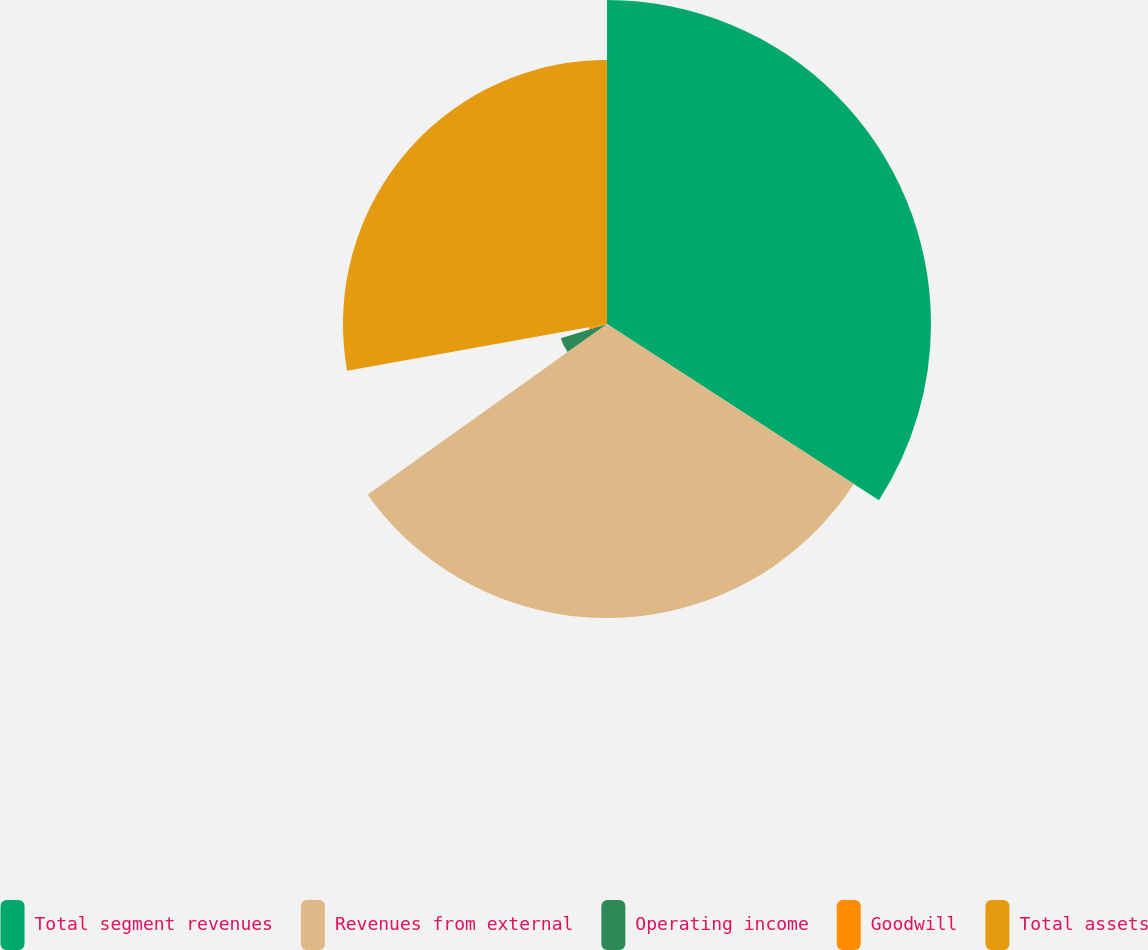Convert chart. <chart><loc_0><loc_0><loc_500><loc_500><pie_chart><fcel>Total segment revenues<fcel>Revenues from external<fcel>Operating income<fcel>Goodwill<fcel>Total assets<nl><fcel>34.15%<fcel>30.99%<fcel>5.1%<fcel>1.93%<fcel>27.83%<nl></chart> 